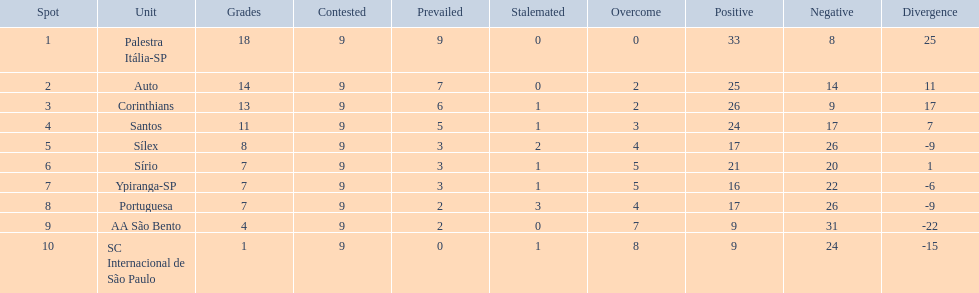Which brazilian team took the top spot in the 1926 brazilian football cup? Palestra Itália-SP. 